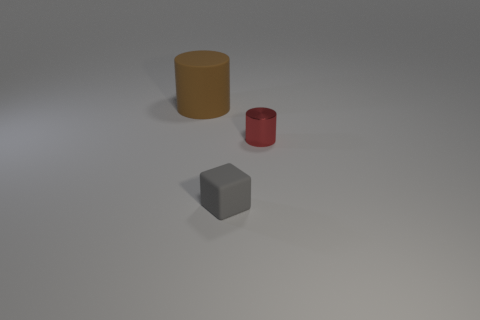There is a matte thing that is the same size as the metal cylinder; what shape is it? The matte object that matches the size of the metal cylinder in the image is a cube. It is a geometrically perfect cube with six equal square faces, and a matte gray texture that contrasts with the lustrous surfaces of the cylinders. 